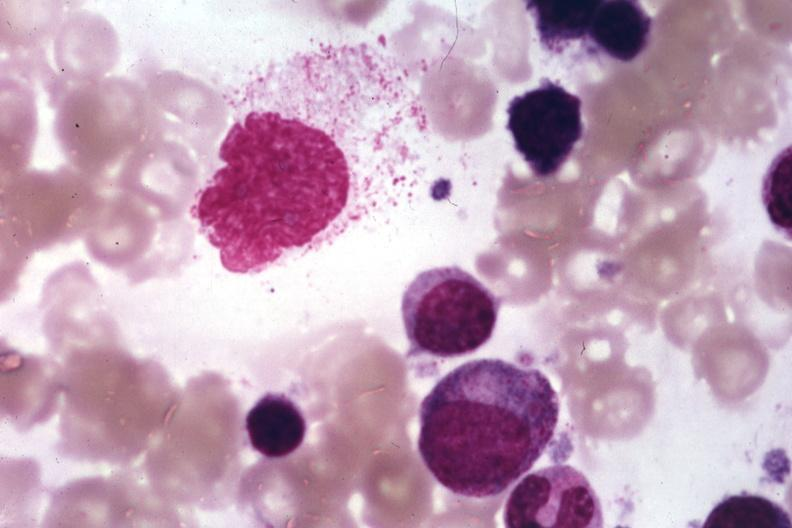s hematologic present?
Answer the question using a single word or phrase. Yes 